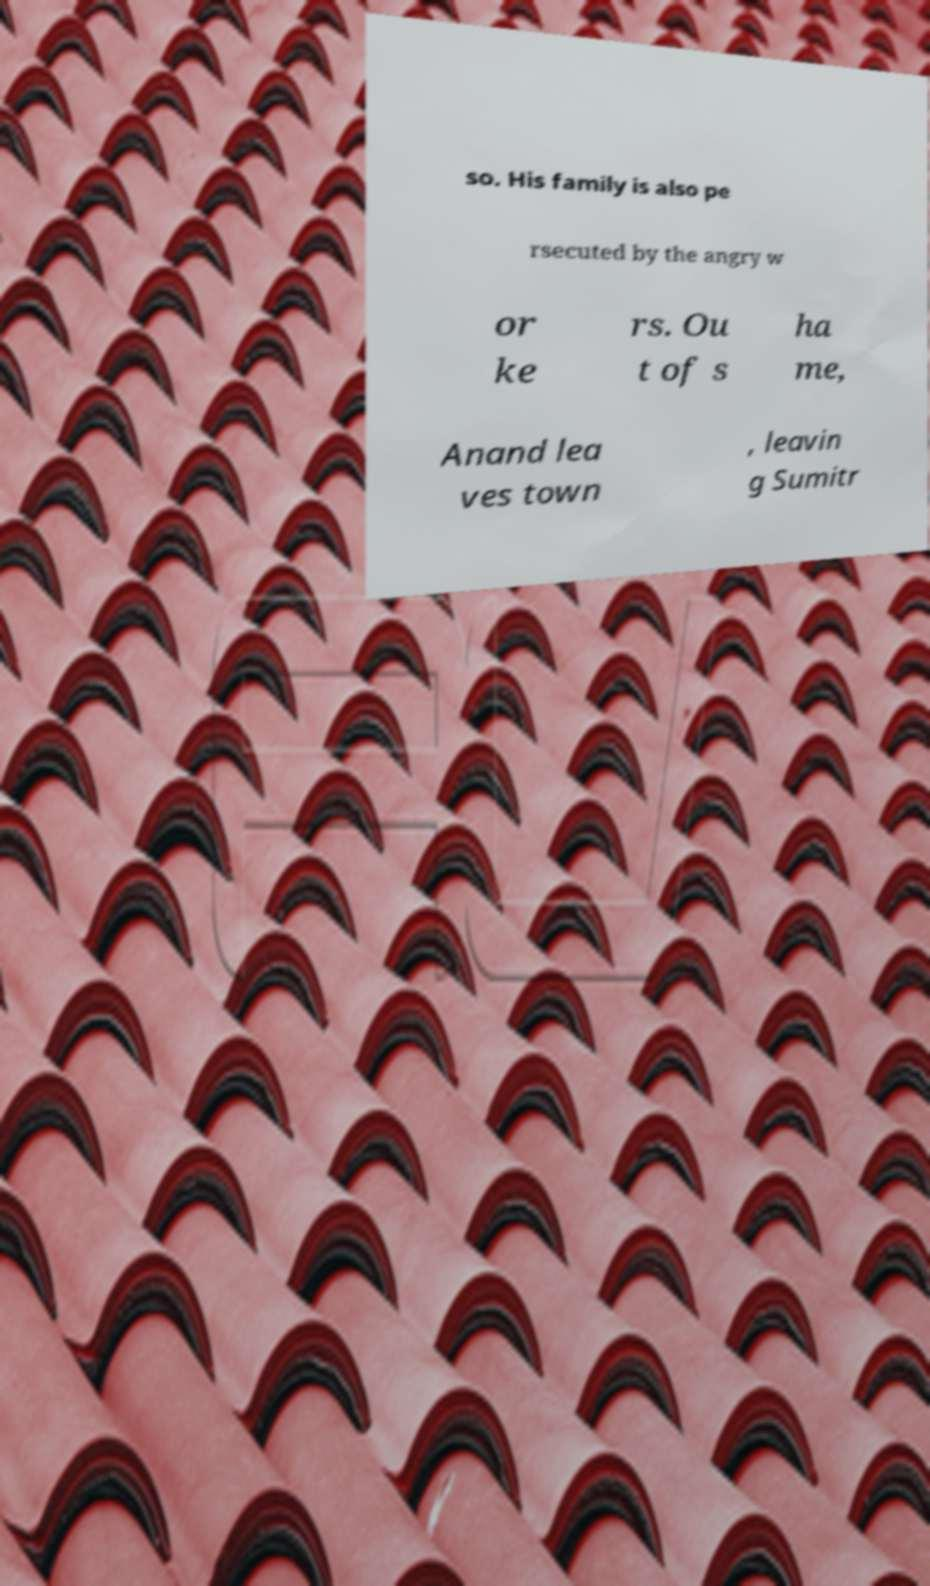There's text embedded in this image that I need extracted. Can you transcribe it verbatim? so. His family is also pe rsecuted by the angry w or ke rs. Ou t of s ha me, Anand lea ves town , leavin g Sumitr 